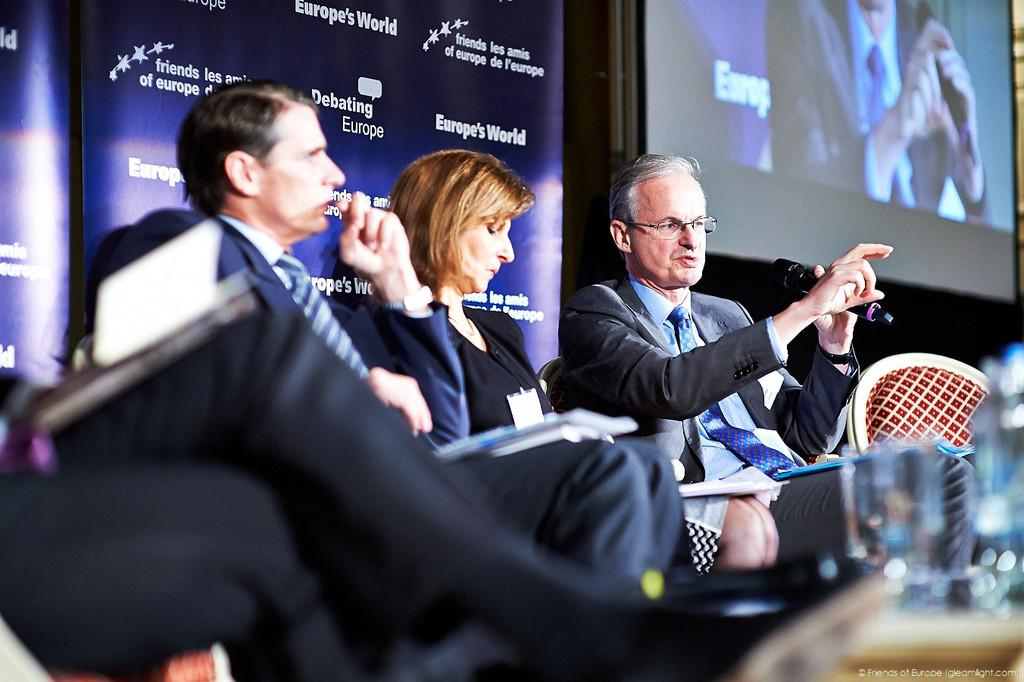How many people are in the image? There are three persons in the image. What are the persons wearing? The persons are wearing suits. What can be seen in the background of the image? There is a screen and banners in the background of the image. Where is the water bottle located in the image? The water bottle is on the right side of the image. Can you see any bats flying around in the image? There are no bats visible in the image. Are there any fairies present in the image? There is no mention of fairies in the provided facts, and therefore they are not present in the image. 